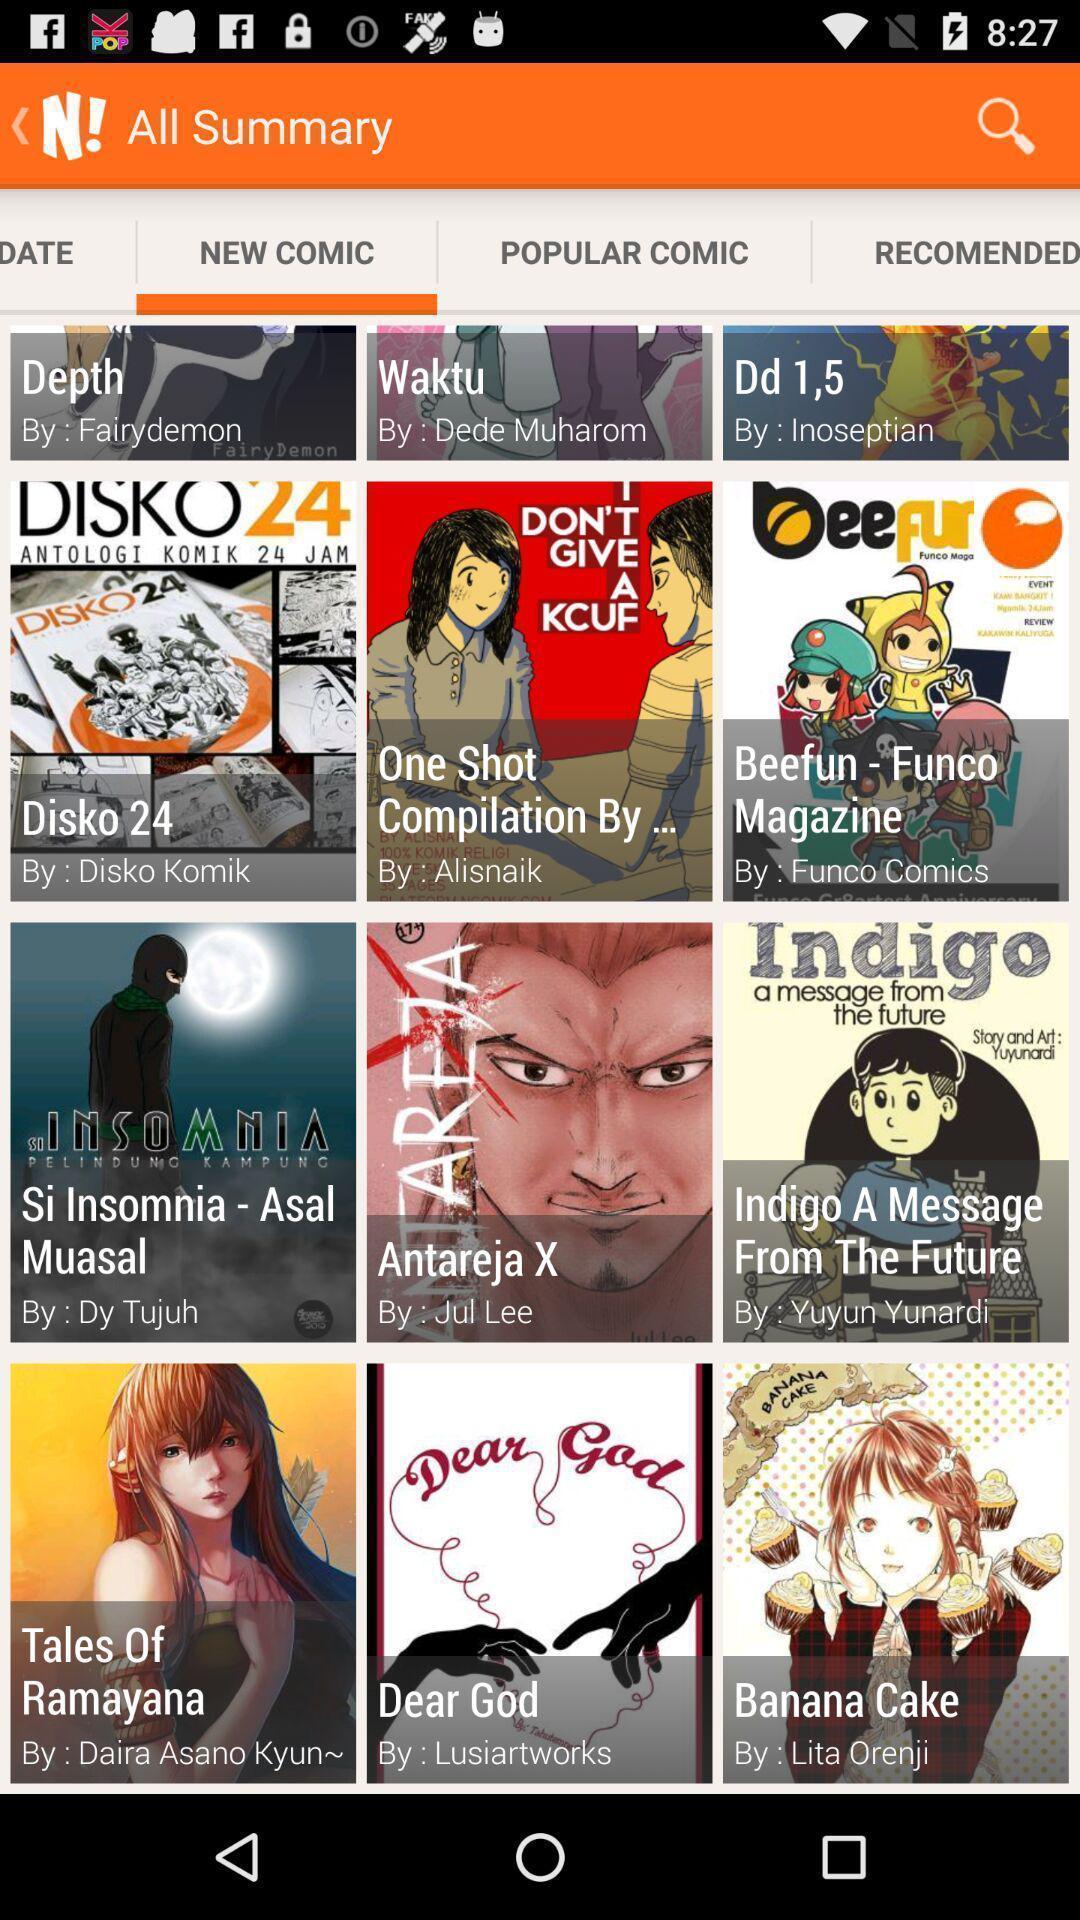What is the overall content of this screenshot? Screen displaying multiple comic names with pictures. 